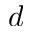Convert formula to latex. <formula><loc_0><loc_0><loc_500><loc_500>d</formula> 